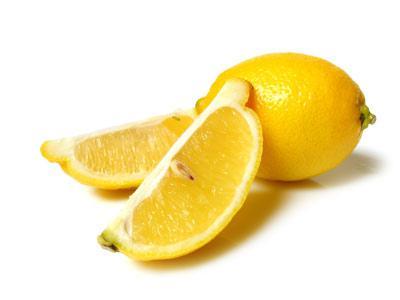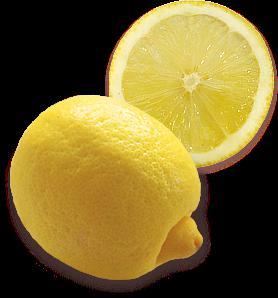The first image is the image on the left, the second image is the image on the right. Considering the images on both sides, is "An image contains exactly one whole lemon next to a lemon that is cut in half, and no green leaves are present." valid? Answer yes or no. Yes. The first image is the image on the left, the second image is the image on the right. Evaluate the accuracy of this statement regarding the images: "The left image contain only two whole lemons.". Is it true? Answer yes or no. No. 